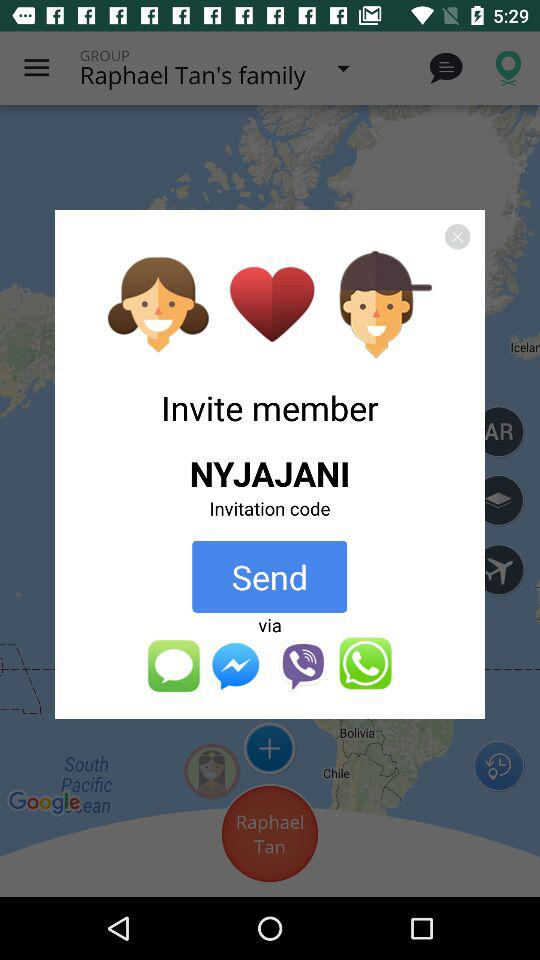What is the name of the user? The user name is Raphael Tan. 